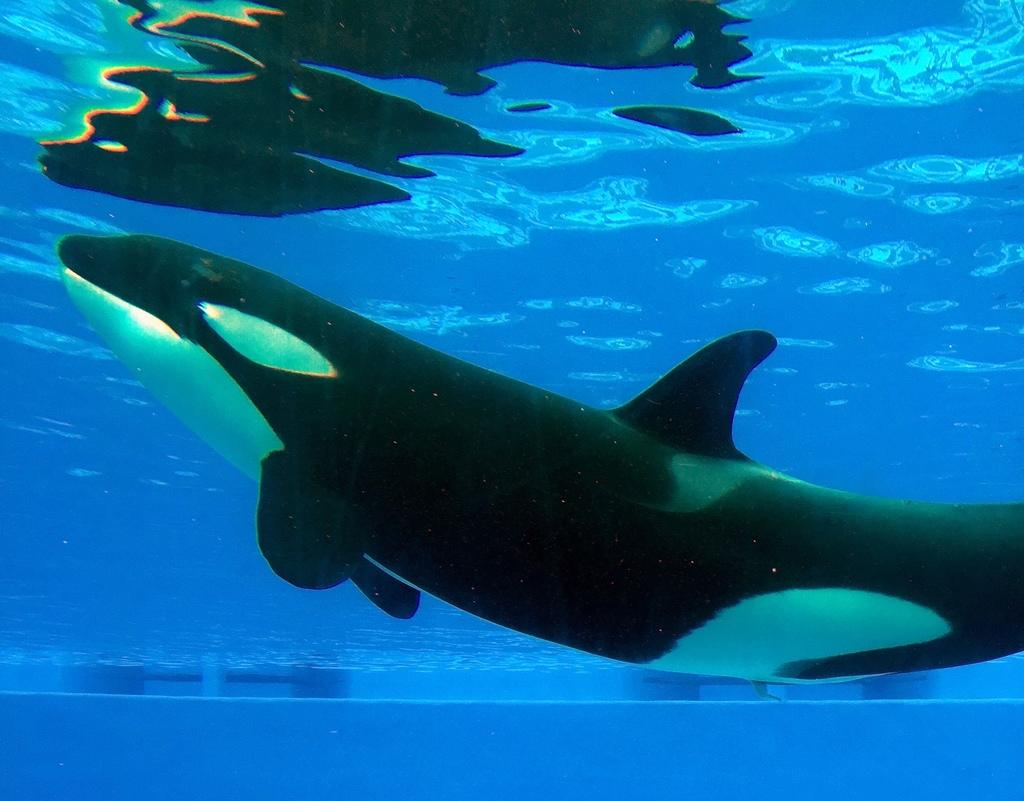What animal is the main subject of the image? There is a whale in the image. Where is the whale located? The whale is in the water. Can you tell me how many teeth the maid has in the image? There is no maid present in the image, and therefore no teeth can be observed. 